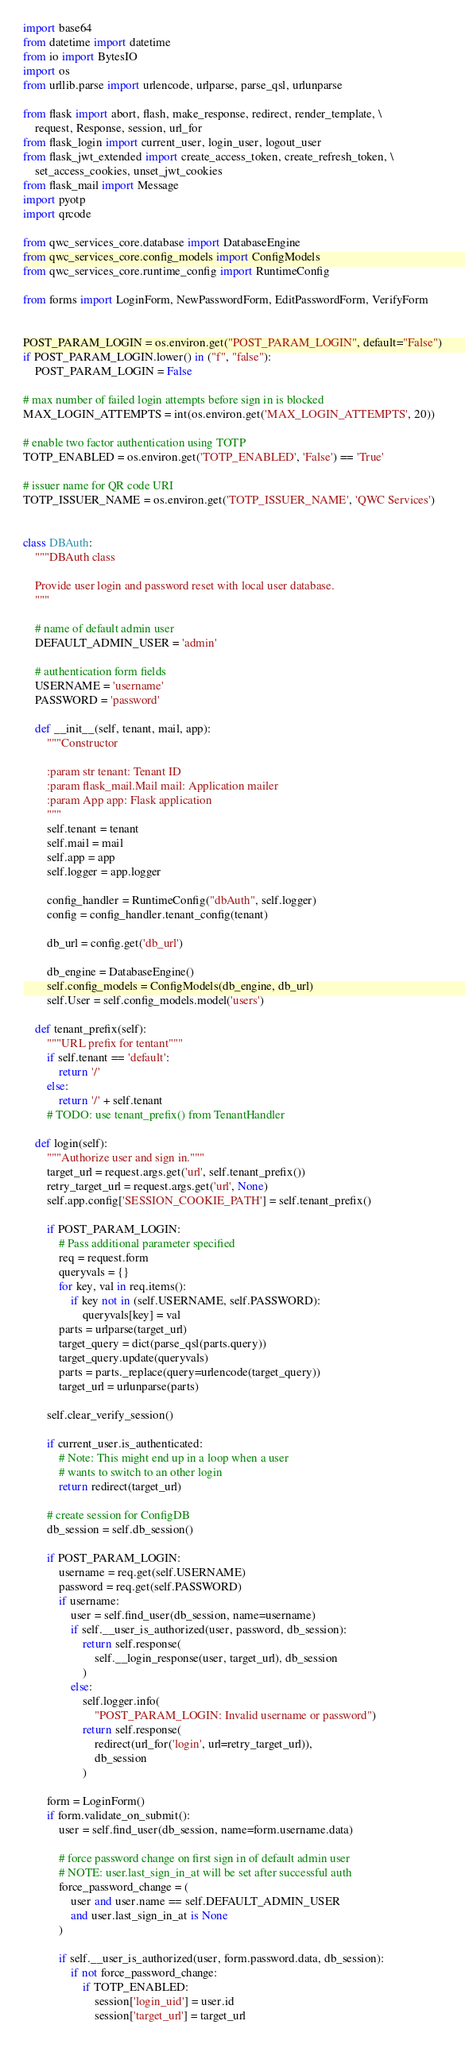<code> <loc_0><loc_0><loc_500><loc_500><_Python_>import base64
from datetime import datetime
from io import BytesIO
import os
from urllib.parse import urlencode, urlparse, parse_qsl, urlunparse

from flask import abort, flash, make_response, redirect, render_template, \
    request, Response, session, url_for
from flask_login import current_user, login_user, logout_user
from flask_jwt_extended import create_access_token, create_refresh_token, \
    set_access_cookies, unset_jwt_cookies
from flask_mail import Message
import pyotp
import qrcode

from qwc_services_core.database import DatabaseEngine
from qwc_services_core.config_models import ConfigModels
from qwc_services_core.runtime_config import RuntimeConfig

from forms import LoginForm, NewPasswordForm, EditPasswordForm, VerifyForm


POST_PARAM_LOGIN = os.environ.get("POST_PARAM_LOGIN", default="False")
if POST_PARAM_LOGIN.lower() in ("f", "false"):
    POST_PARAM_LOGIN = False

# max number of failed login attempts before sign in is blocked
MAX_LOGIN_ATTEMPTS = int(os.environ.get('MAX_LOGIN_ATTEMPTS', 20))

# enable two factor authentication using TOTP
TOTP_ENABLED = os.environ.get('TOTP_ENABLED', 'False') == 'True'

# issuer name for QR code URI
TOTP_ISSUER_NAME = os.environ.get('TOTP_ISSUER_NAME', 'QWC Services')


class DBAuth:
    """DBAuth class

    Provide user login and password reset with local user database.
    """

    # name of default admin user
    DEFAULT_ADMIN_USER = 'admin'

    # authentication form fields
    USERNAME = 'username'
    PASSWORD = 'password'

    def __init__(self, tenant, mail, app):
        """Constructor

        :param str tenant: Tenant ID
        :param flask_mail.Mail mail: Application mailer
        :param App app: Flask application
        """
        self.tenant = tenant
        self.mail = mail
        self.app = app
        self.logger = app.logger

        config_handler = RuntimeConfig("dbAuth", self.logger)
        config = config_handler.tenant_config(tenant)

        db_url = config.get('db_url')

        db_engine = DatabaseEngine()
        self.config_models = ConfigModels(db_engine, db_url)
        self.User = self.config_models.model('users')

    def tenant_prefix(self):
        """URL prefix for tentant"""
        if self.tenant == 'default':
            return '/'
        else:
            return '/' + self.tenant
        # TODO: use tenant_prefix() from TenantHandler

    def login(self):
        """Authorize user and sign in."""
        target_url = request.args.get('url', self.tenant_prefix())
        retry_target_url = request.args.get('url', None)
        self.app.config['SESSION_COOKIE_PATH'] = self.tenant_prefix()

        if POST_PARAM_LOGIN:
            # Pass additional parameter specified
            req = request.form
            queryvals = {}
            for key, val in req.items():
                if key not in (self.USERNAME, self.PASSWORD):
                    queryvals[key] = val
            parts = urlparse(target_url)
            target_query = dict(parse_qsl(parts.query))
            target_query.update(queryvals)
            parts = parts._replace(query=urlencode(target_query))
            target_url = urlunparse(parts)

        self.clear_verify_session()

        if current_user.is_authenticated:
            # Note: This might end up in a loop when a user
            # wants to switch to an other login
            return redirect(target_url)

        # create session for ConfigDB
        db_session = self.db_session()

        if POST_PARAM_LOGIN:
            username = req.get(self.USERNAME)
            password = req.get(self.PASSWORD)
            if username:
                user = self.find_user(db_session, name=username)
                if self.__user_is_authorized(user, password, db_session):
                    return self.response(
                        self.__login_response(user, target_url), db_session
                    )
                else:
                    self.logger.info(
                        "POST_PARAM_LOGIN: Invalid username or password")
                    return self.response(
                        redirect(url_for('login', url=retry_target_url)),
                        db_session
                    )

        form = LoginForm()
        if form.validate_on_submit():
            user = self.find_user(db_session, name=form.username.data)

            # force password change on first sign in of default admin user
            # NOTE: user.last_sign_in_at will be set after successful auth
            force_password_change = (
                user and user.name == self.DEFAULT_ADMIN_USER
                and user.last_sign_in_at is None
            )

            if self.__user_is_authorized(user, form.password.data, db_session):
                if not force_password_change:
                    if TOTP_ENABLED:
                        session['login_uid'] = user.id
                        session['target_url'] = target_url</code> 